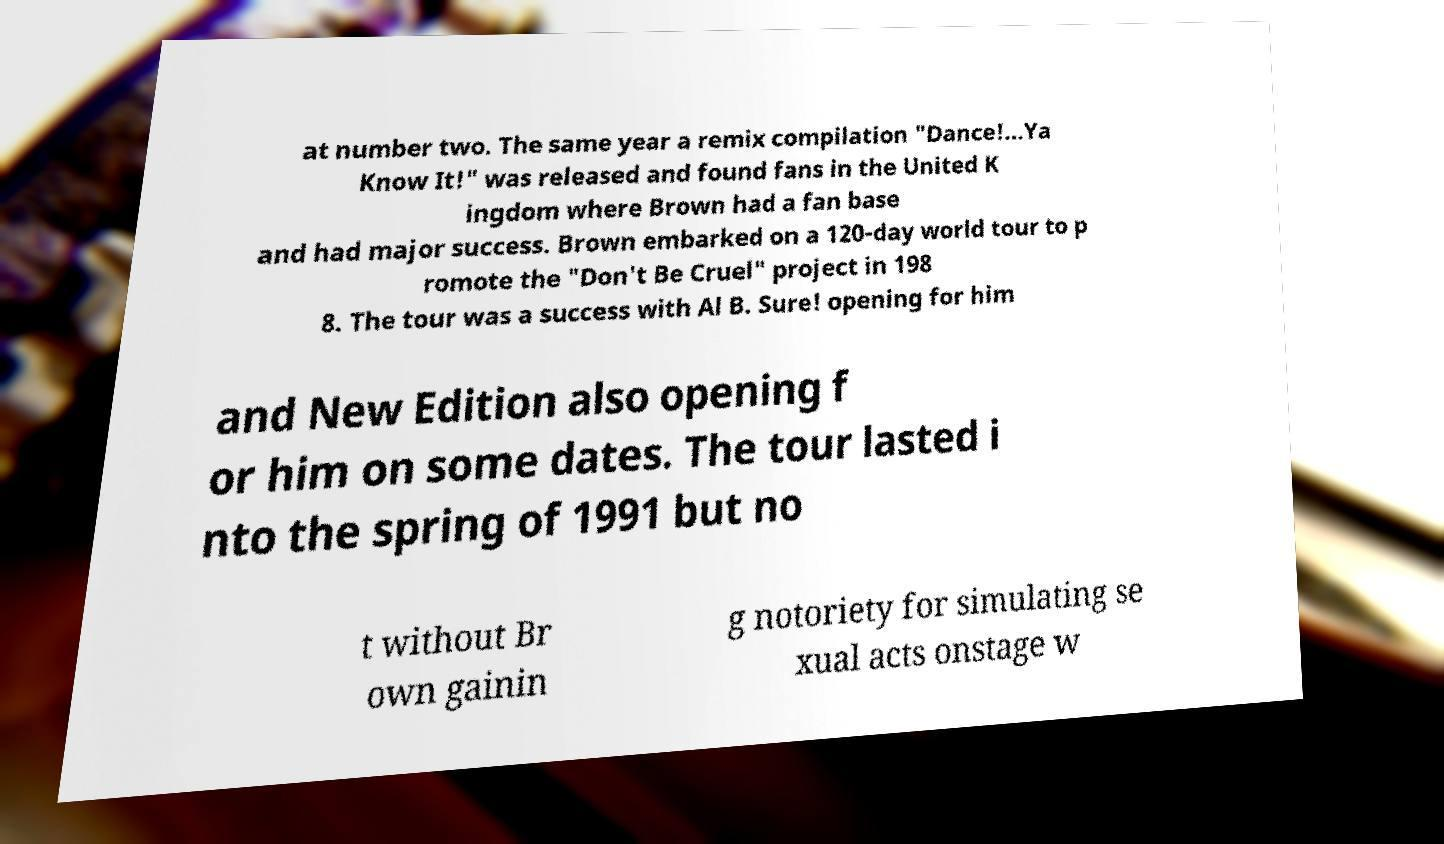Can you read and provide the text displayed in the image?This photo seems to have some interesting text. Can you extract and type it out for me? at number two. The same year a remix compilation "Dance!...Ya Know It!" was released and found fans in the United K ingdom where Brown had a fan base and had major success. Brown embarked on a 120-day world tour to p romote the "Don't Be Cruel" project in 198 8. The tour was a success with Al B. Sure! opening for him and New Edition also opening f or him on some dates. The tour lasted i nto the spring of 1991 but no t without Br own gainin g notoriety for simulating se xual acts onstage w 